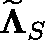Convert formula to latex. <formula><loc_0><loc_0><loc_500><loc_500>\widetilde { \Lambda } _ { S }</formula> 